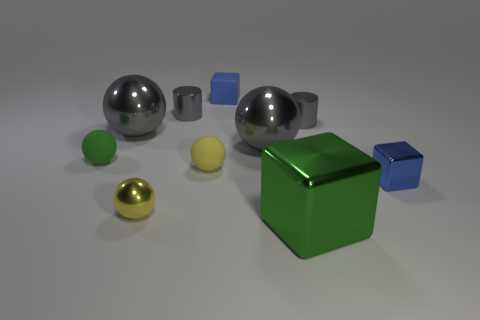Subtract all red cubes. Subtract all blue spheres. How many cubes are left? 3 Subtract all yellow cubes. How many blue cylinders are left? 0 Add 7 tiny things. How many large grays exist? 0 Subtract all small yellow matte spheres. Subtract all small green objects. How many objects are left? 8 Add 6 metal spheres. How many metal spheres are left? 9 Add 1 small red blocks. How many small red blocks exist? 1 Subtract all blue cubes. How many cubes are left? 1 Subtract all small shiny balls. How many balls are left? 4 Subtract 0 yellow cylinders. How many objects are left? 10 Subtract all yellow balls. How many were subtracted if there are1yellow balls left? 1 